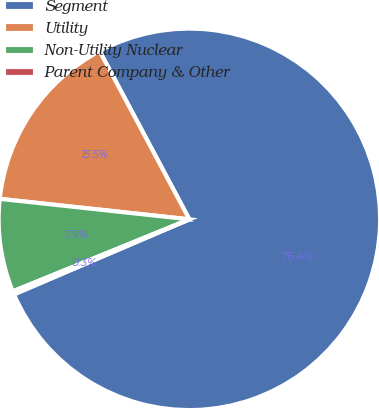Convert chart to OTSL. <chart><loc_0><loc_0><loc_500><loc_500><pie_chart><fcel>Segment<fcel>Utility<fcel>Non-Utility Nuclear<fcel>Parent Company & Other<nl><fcel>76.37%<fcel>15.49%<fcel>7.88%<fcel>0.27%<nl></chart> 